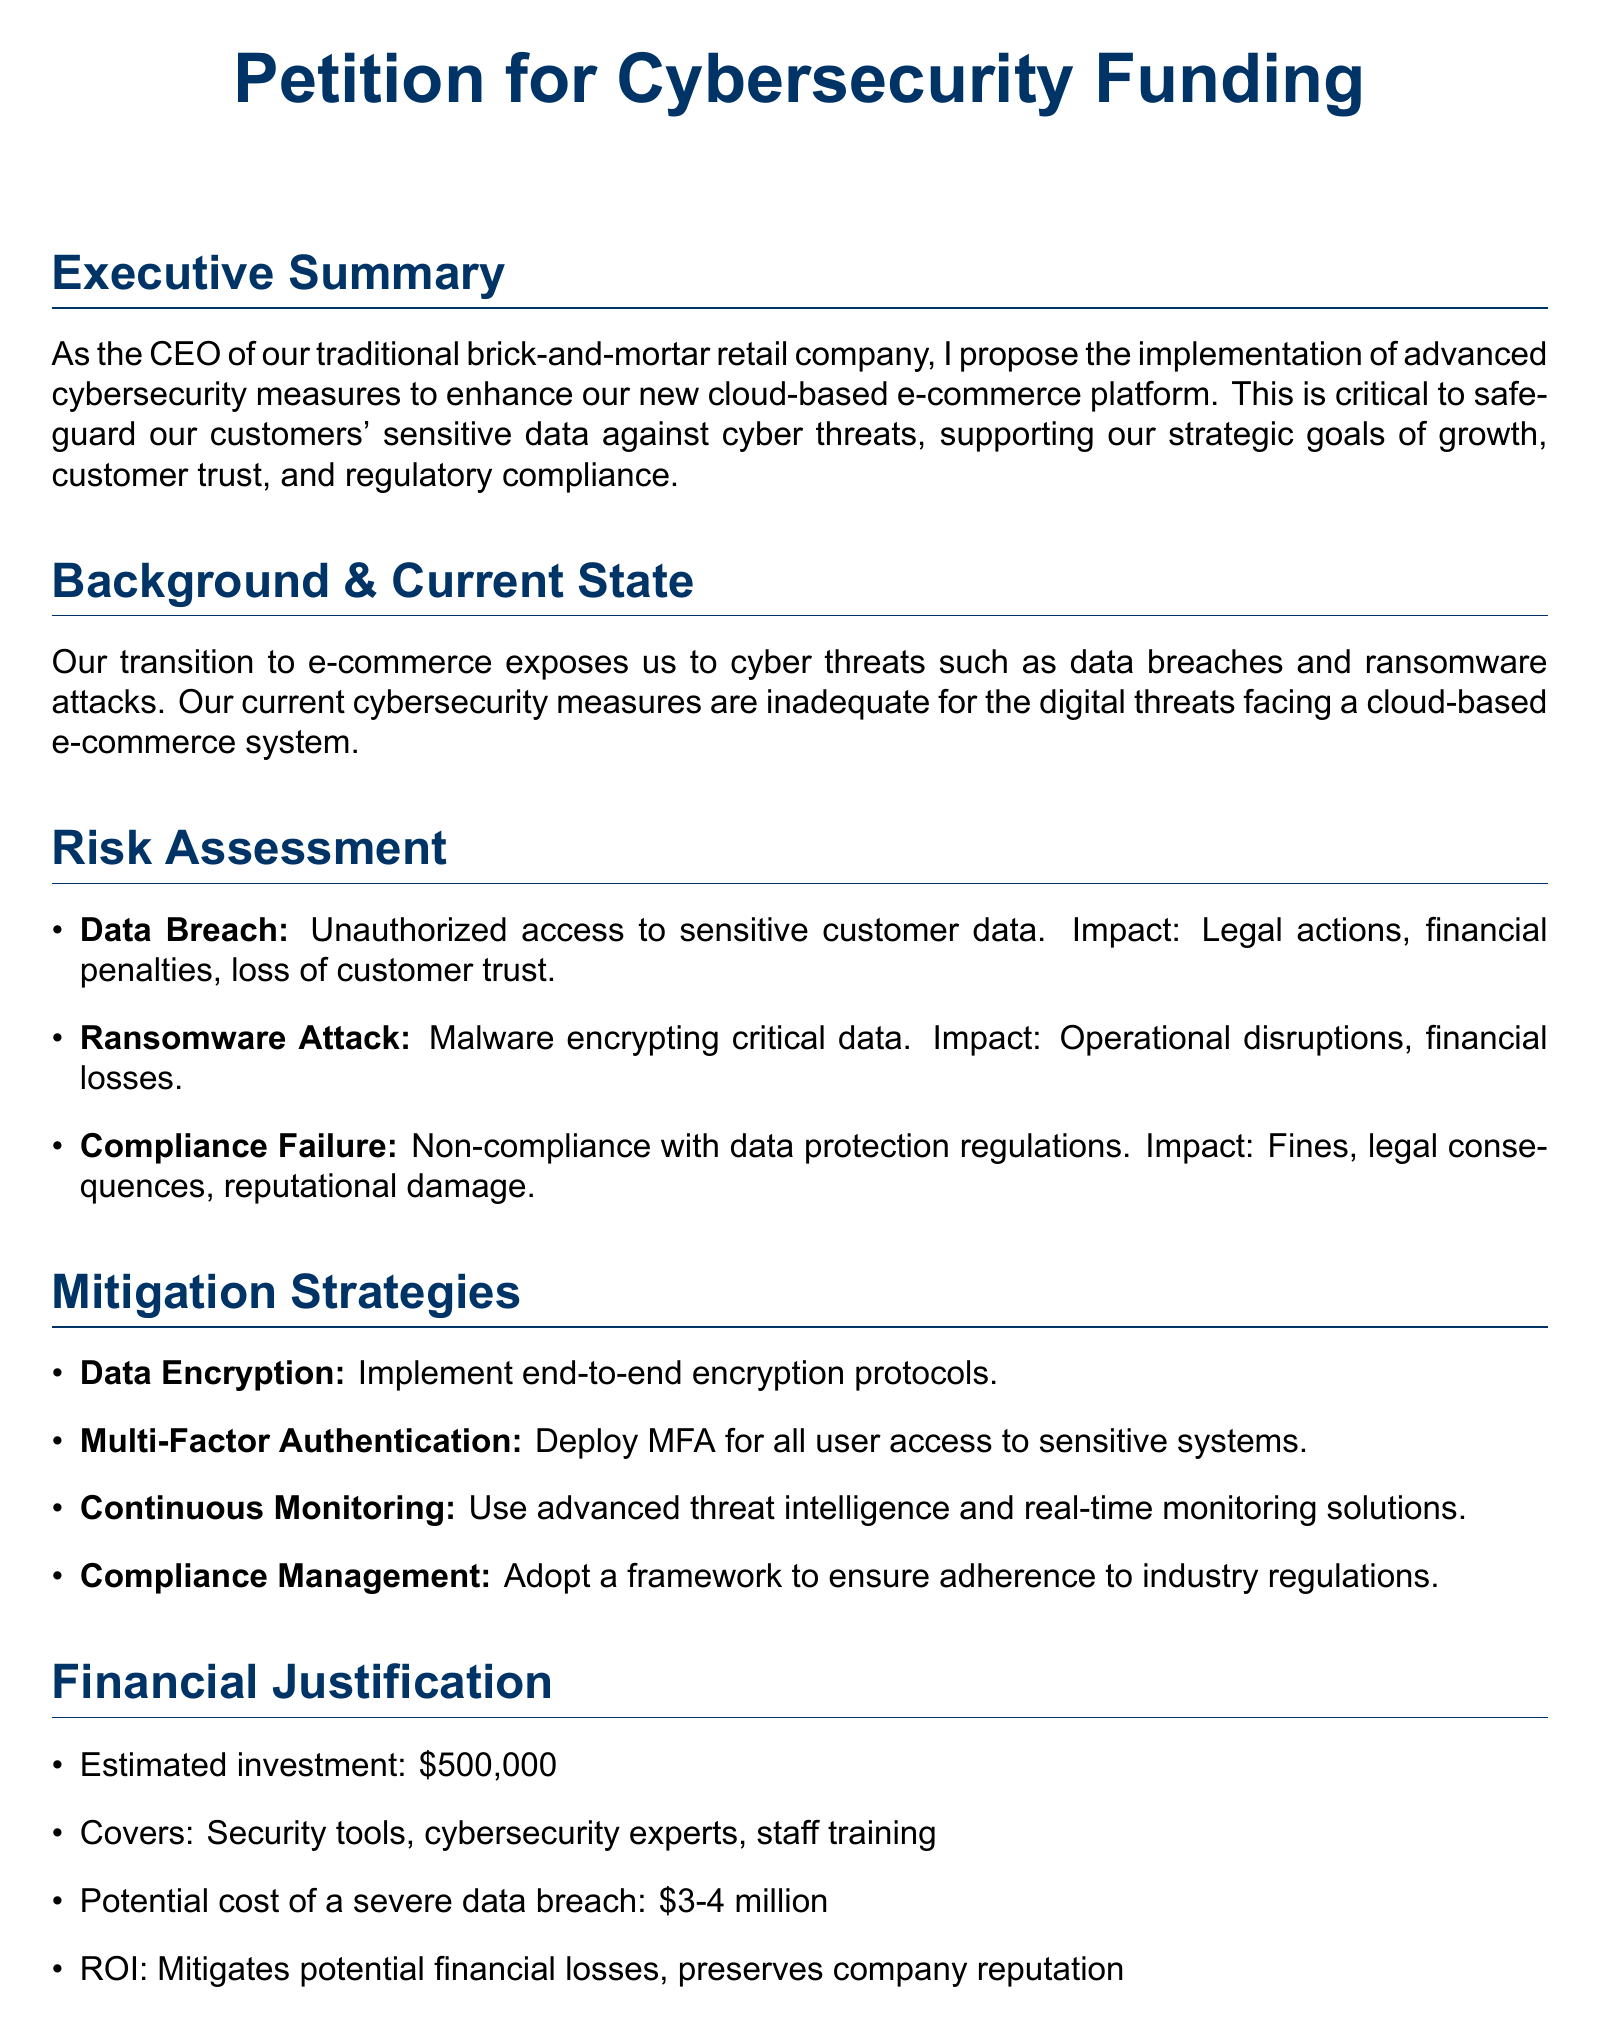What is the estimated investment for cybersecurity measures? The estimated investment mentioned in the financial justification section is $500,000.
Answer: $500,000 What are the potential costs of a severe data breach? The financial justification states that the potential cost of a severe data breach is between $3 million and $4 million.
Answer: $3-4 million What is one of the impacts of a data breach? The document lists legal actions, financial penalties, and loss of customer trust as impacts arising from a data breach.
Answer: Legal actions What implementation measure involves securing user access? The mitigation strategies include deploying Multi-Factor Authentication (MFA) for all user access to sensitive systems.
Answer: Multi-Factor Authentication What does the requested action seek approval for? The requested action in the conclusion is to approve $500,000 funding for advanced cybersecurity measures.
Answer: $500,000 funding What type of monitoring is suggested for cybersecurity? The document recommends using advanced threat intelligence and real-time monitoring solutions as part of the continuous monitoring strategy.
Answer: Continuous Monitoring What compliance issue may result from inadequate cybersecurity? Non-compliance with data protection regulations is a challenge highlighted under risk assessment for causing fines, legal consequences, and reputational damage.
Answer: Compliance Failure How does the document classify itself? The document includes a title indicating that it is a Petition for Cybersecurity Funding.
Answer: Petition for Cybersecurity Funding What is one key cybersecurity measure proposed? One of the proposed mitigation strategies is to implement end-to-end encryption protocols.
Answer: Data Encryption 